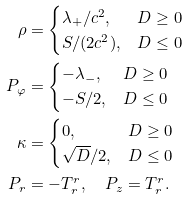<formula> <loc_0><loc_0><loc_500><loc_500>\rho & = \begin{cases} \lambda _ { + } / c ^ { 2 } , & D \geq 0 \\ S / ( 2 c ^ { 2 } ) , & D \leq 0 \end{cases} \\ P _ { \varphi } & = \begin{cases} - \lambda _ { - } , & D \geq 0 \\ - S / 2 , & D \leq 0 \end{cases} \\ \kappa & = \begin{cases} 0 , & D \geq 0 \\ \sqrt { D } / 2 , & D \leq 0 \end{cases} \\ P _ { r } & = - T ^ { r } _ { r } , \quad P _ { z } = T ^ { r } _ { r } .</formula> 